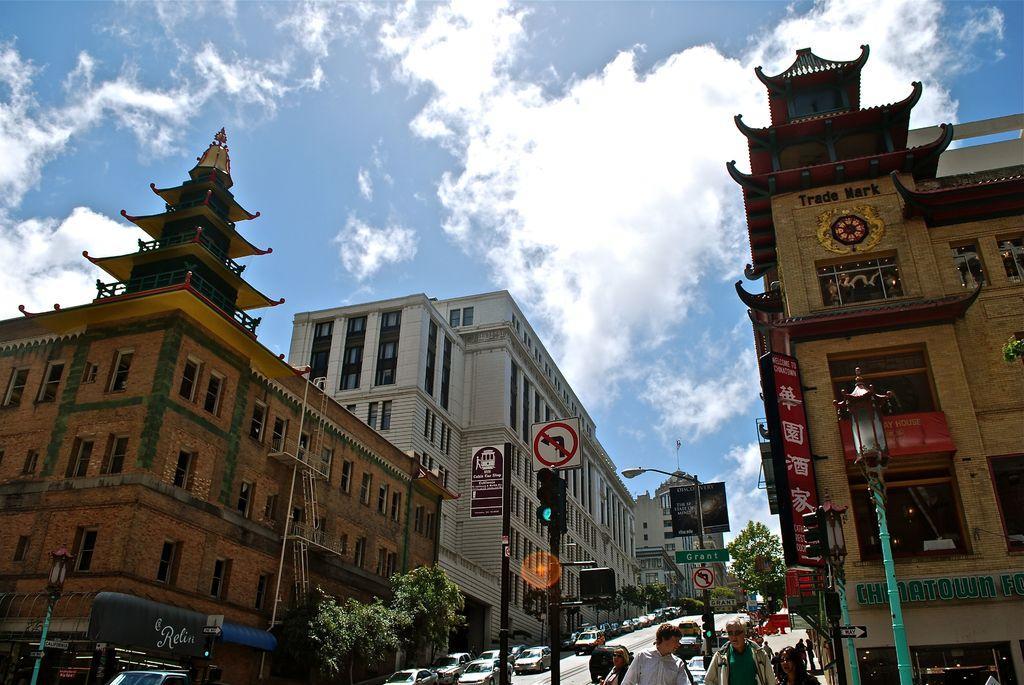Describe this image in one or two sentences. In this picture we can see a group of people standing on the pathway. On the left and right side of the people there are poles with lights, sign boards, traffic signals and a directional board. On the right side of the poles there is a building with names boards. On the left side of the poles there are trees and vehicles on the road. On the left side of the vehicles there are buildings. Behind the buildings there is the sky. 